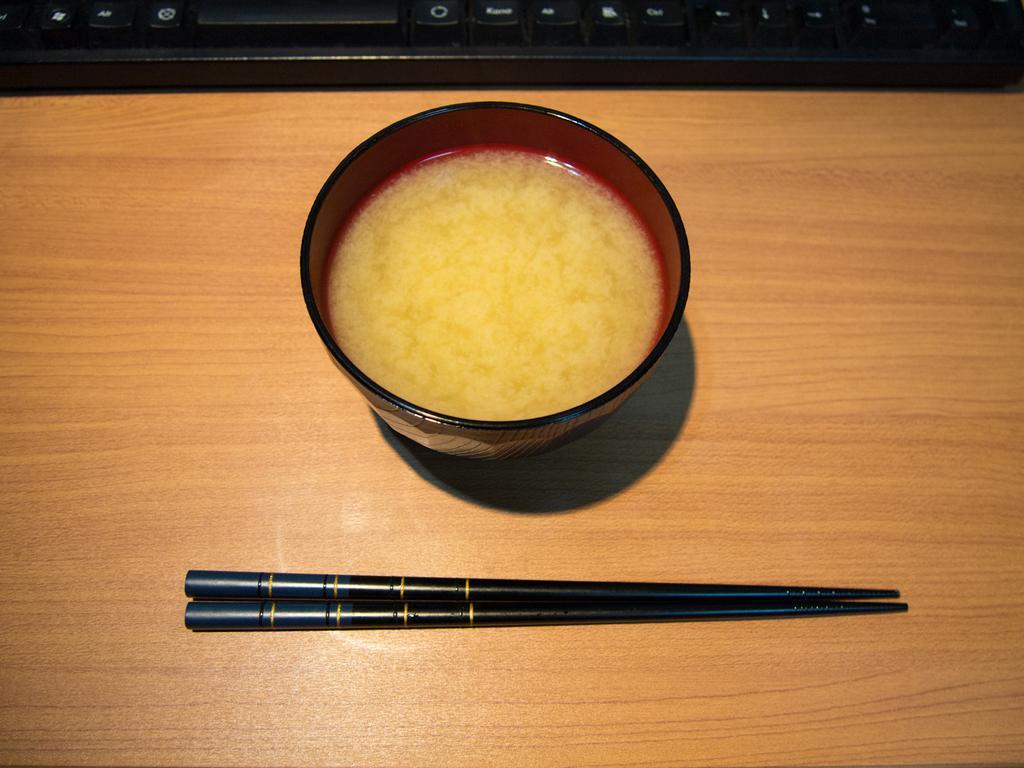In one or two sentences, can you explain what this image depicts? This is the picture of a table on which there is a cup, keyboard and a fork. 